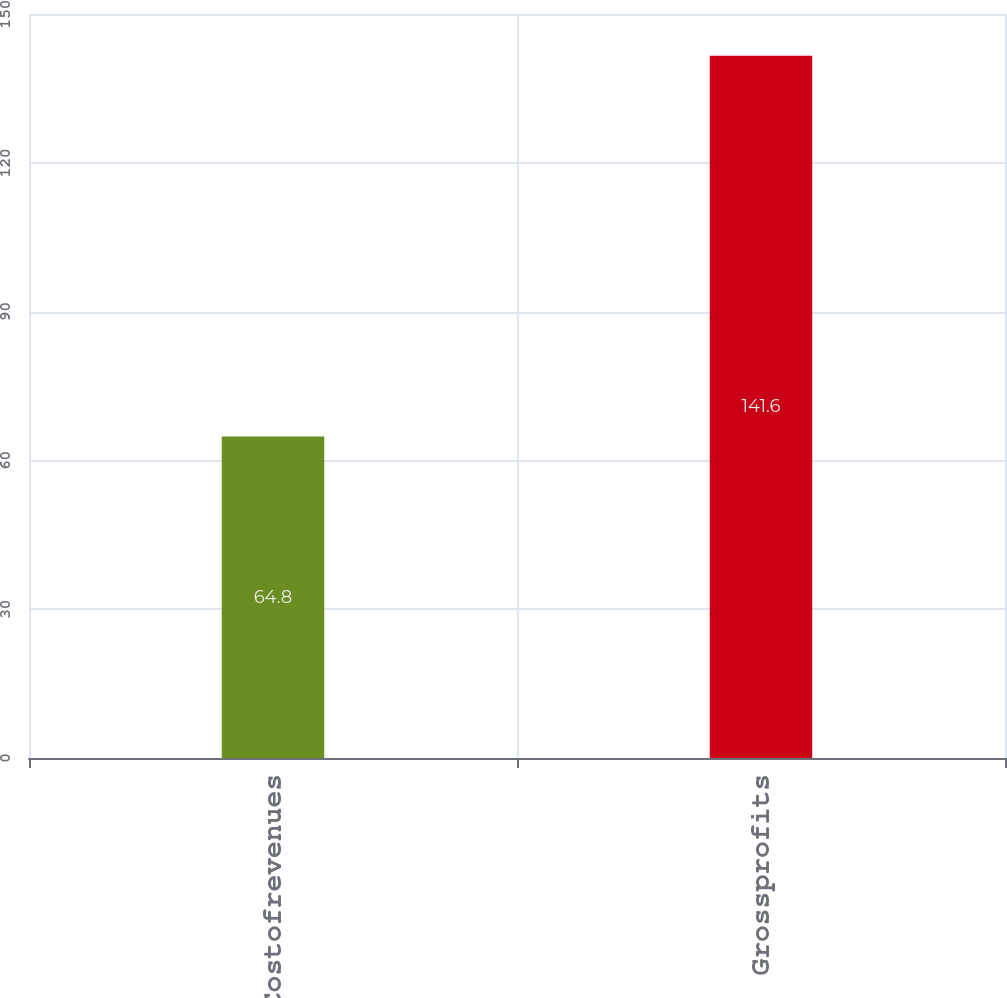Convert chart to OTSL. <chart><loc_0><loc_0><loc_500><loc_500><bar_chart><fcel>Costofrevenues<fcel>Grossprofits<nl><fcel>64.8<fcel>141.6<nl></chart> 